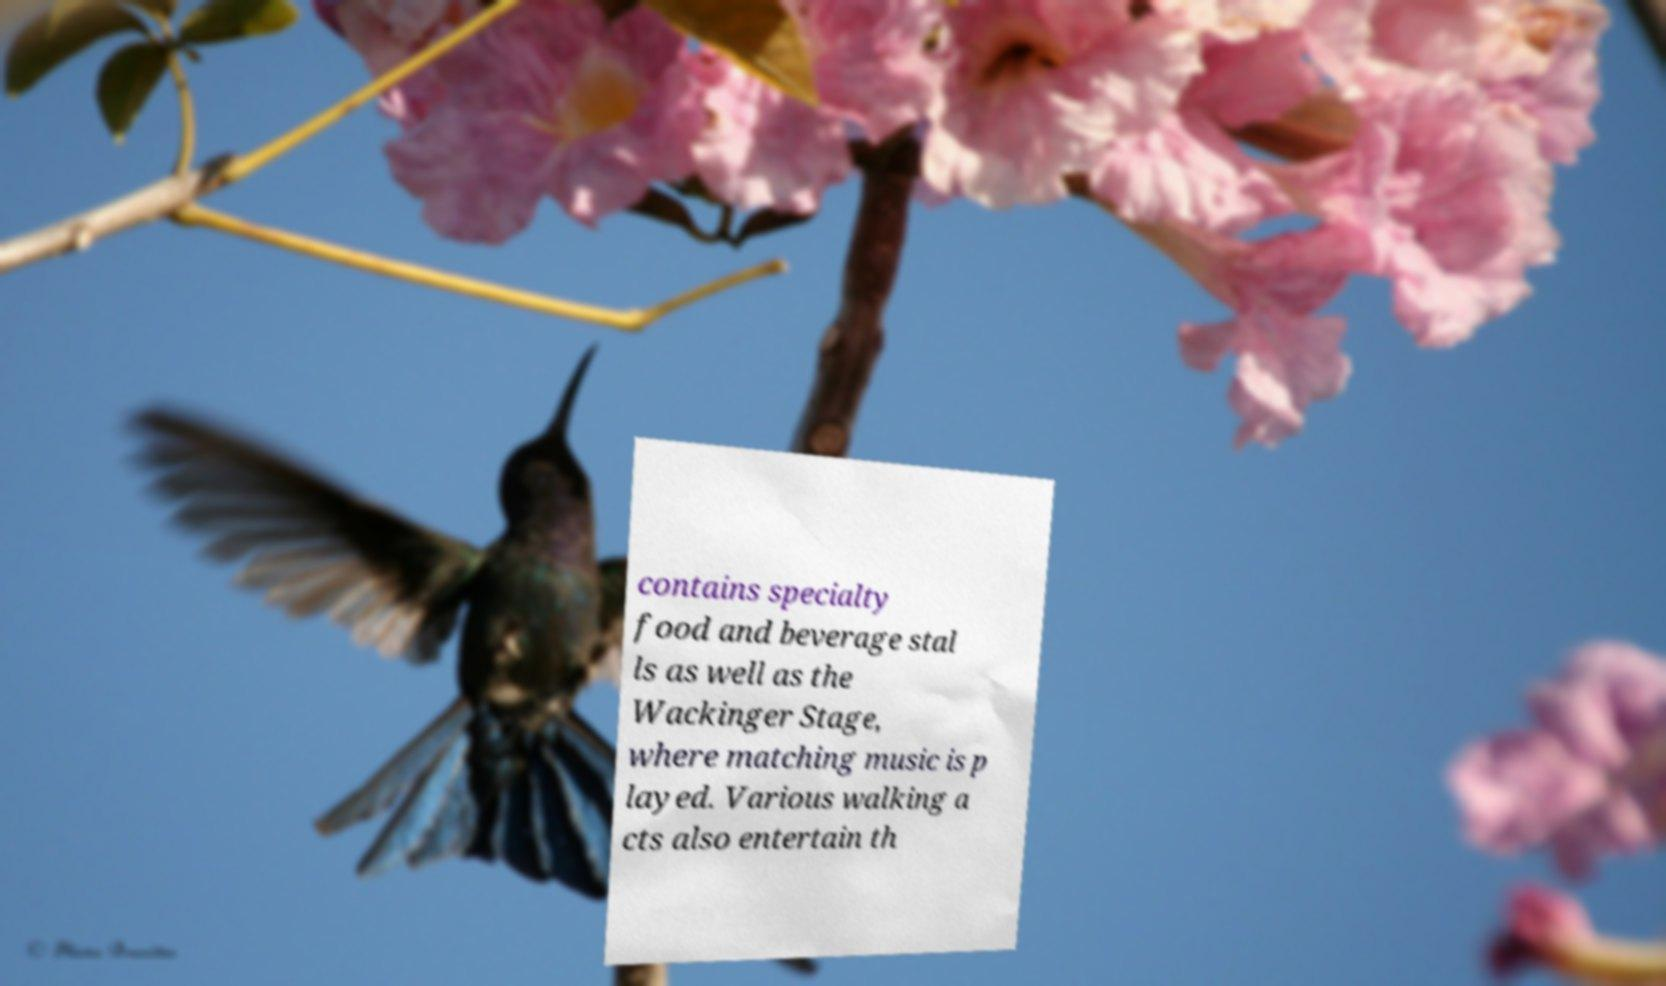Please identify and transcribe the text found in this image. contains specialty food and beverage stal ls as well as the Wackinger Stage, where matching music is p layed. Various walking a cts also entertain th 